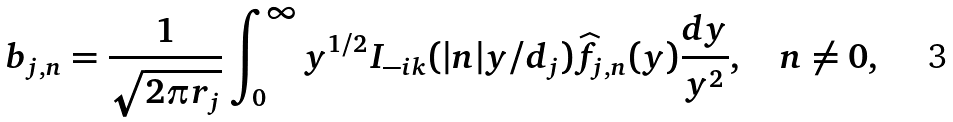Convert formula to latex. <formula><loc_0><loc_0><loc_500><loc_500>b _ { j , n } = \frac { 1 } { \sqrt { 2 \pi r _ { j } } } \int _ { 0 } ^ { \infty } y ^ { 1 / 2 } I _ { - i k } ( | n | y / d _ { j } ) \widehat { f } _ { j , n } ( y ) \frac { d y } { y ^ { 2 } } , \quad n \neq 0 ,</formula> 